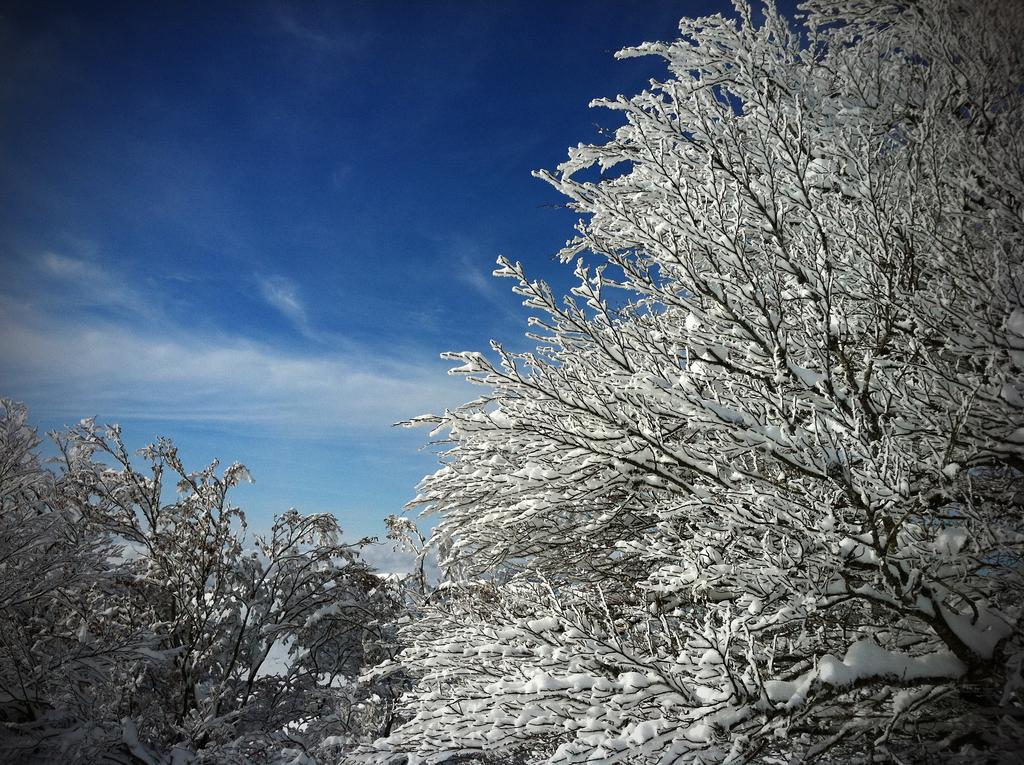What type of vegetation can be seen in the image? There are trees in the image. What is covering the branches of the trees? Snow is present on the branches of the trees. What can be seen in the background of the image? The sky and clouds are visible in the background of the image. What color of sock is hanging on the tree in the image? There are no socks present in the image; it features trees with snow on their branches. What type of paint is being used to create the clouds in the image? The image is a photograph and does not involve paint; the clouds are naturally occurring in the sky. 